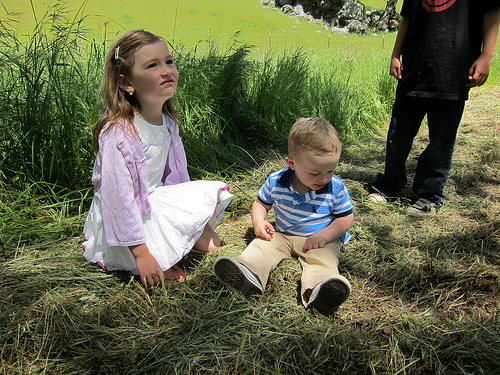<image>
Is there a baby to the left of the girl? No. The baby is not to the left of the girl. From this viewpoint, they have a different horizontal relationship. Is the plant behind the girl? Yes. From this viewpoint, the plant is positioned behind the girl, with the girl partially or fully occluding the plant. Is the child in front of the girl? Yes. The child is positioned in front of the girl, appearing closer to the camera viewpoint. 